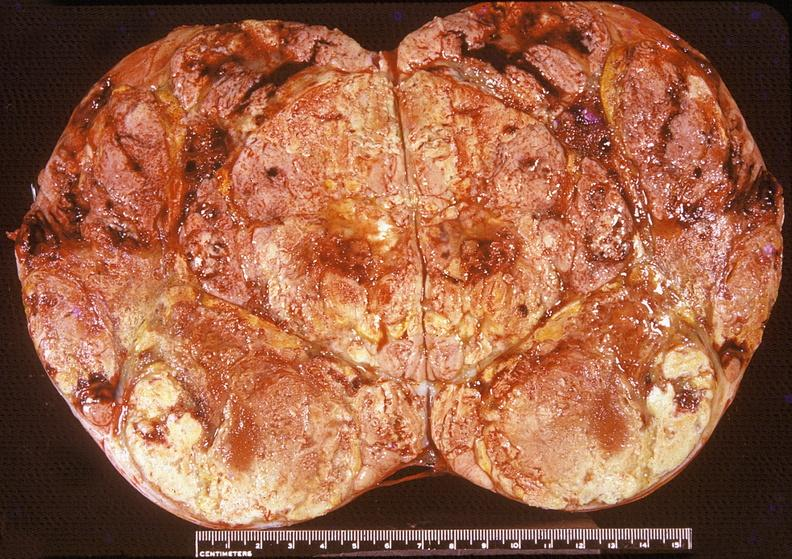s endocrine present?
Answer the question using a single word or phrase. Yes 